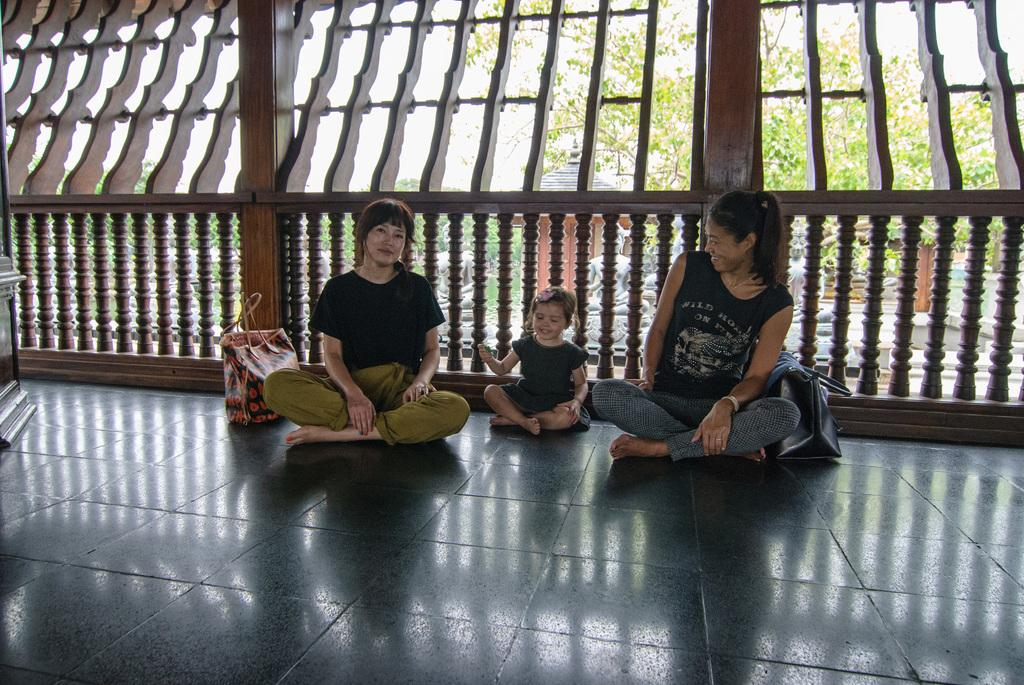How many people are in the image? There are two women and a girl in the image. What are the people in the image doing? They are seated on the floor. What object can be seen in the image besides the people? There is a bag in the image. What is visible in the background of the image? There is a wooden fence, trees, and statues visible through the fence. What color is the elbow of the girl in the image? There is no mention of an elbow in the image, as the people are seated on the floor. 